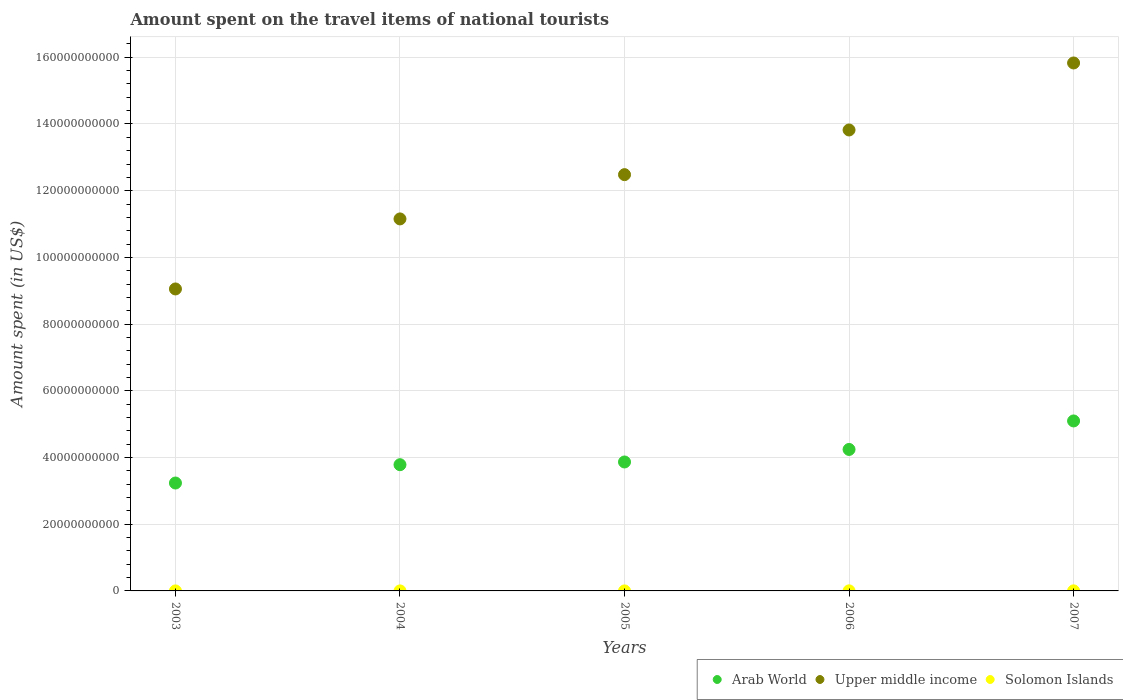What is the amount spent on the travel items of national tourists in Solomon Islands in 2007?
Your response must be concise. 2.26e+07. Across all years, what is the maximum amount spent on the travel items of national tourists in Upper middle income?
Your response must be concise. 1.58e+11. Across all years, what is the minimum amount spent on the travel items of national tourists in Solomon Islands?
Give a very brief answer. 1.50e+06. What is the total amount spent on the travel items of national tourists in Arab World in the graph?
Your response must be concise. 2.02e+11. What is the difference between the amount spent on the travel items of national tourists in Solomon Islands in 2004 and that in 2005?
Your answer should be very brief. 1.90e+06. What is the difference between the amount spent on the travel items of national tourists in Upper middle income in 2004 and the amount spent on the travel items of national tourists in Arab World in 2005?
Provide a succinct answer. 7.29e+1. What is the average amount spent on the travel items of national tourists in Solomon Islands per year?
Keep it short and to the point. 1.01e+07. In the year 2004, what is the difference between the amount spent on the travel items of national tourists in Solomon Islands and amount spent on the travel items of national tourists in Upper middle income?
Provide a short and direct response. -1.12e+11. In how many years, is the amount spent on the travel items of national tourists in Arab World greater than 16000000000 US$?
Give a very brief answer. 5. What is the ratio of the amount spent on the travel items of national tourists in Solomon Islands in 2005 to that in 2006?
Provide a short and direct response. 0.08. Is the difference between the amount spent on the travel items of national tourists in Solomon Islands in 2004 and 2005 greater than the difference between the amount spent on the travel items of national tourists in Upper middle income in 2004 and 2005?
Keep it short and to the point. Yes. What is the difference between the highest and the second highest amount spent on the travel items of national tourists in Arab World?
Your answer should be compact. 8.55e+09. What is the difference between the highest and the lowest amount spent on the travel items of national tourists in Arab World?
Keep it short and to the point. 1.86e+1. Is the sum of the amount spent on the travel items of national tourists in Arab World in 2004 and 2007 greater than the maximum amount spent on the travel items of national tourists in Solomon Islands across all years?
Make the answer very short. Yes. Is it the case that in every year, the sum of the amount spent on the travel items of national tourists in Solomon Islands and amount spent on the travel items of national tourists in Arab World  is greater than the amount spent on the travel items of national tourists in Upper middle income?
Make the answer very short. No. Does the amount spent on the travel items of national tourists in Upper middle income monotonically increase over the years?
Keep it short and to the point. Yes. Is the amount spent on the travel items of national tourists in Upper middle income strictly greater than the amount spent on the travel items of national tourists in Arab World over the years?
Offer a very short reply. Yes. Are the values on the major ticks of Y-axis written in scientific E-notation?
Give a very brief answer. No. Where does the legend appear in the graph?
Give a very brief answer. Bottom right. How many legend labels are there?
Keep it short and to the point. 3. What is the title of the graph?
Give a very brief answer. Amount spent on the travel items of national tourists. Does "American Samoa" appear as one of the legend labels in the graph?
Your response must be concise. No. What is the label or title of the X-axis?
Your answer should be compact. Years. What is the label or title of the Y-axis?
Ensure brevity in your answer.  Amount spent (in US$). What is the Amount spent (in US$) of Arab World in 2003?
Offer a very short reply. 3.24e+1. What is the Amount spent (in US$) of Upper middle income in 2003?
Keep it short and to the point. 9.05e+1. What is the Amount spent (in US$) in Solomon Islands in 2003?
Keep it short and to the point. 1.50e+06. What is the Amount spent (in US$) in Arab World in 2004?
Offer a very short reply. 3.78e+1. What is the Amount spent (in US$) in Upper middle income in 2004?
Provide a succinct answer. 1.12e+11. What is the Amount spent (in US$) in Solomon Islands in 2004?
Your answer should be compact. 3.50e+06. What is the Amount spent (in US$) in Arab World in 2005?
Ensure brevity in your answer.  3.87e+1. What is the Amount spent (in US$) of Upper middle income in 2005?
Offer a terse response. 1.25e+11. What is the Amount spent (in US$) of Solomon Islands in 2005?
Your answer should be compact. 1.60e+06. What is the Amount spent (in US$) in Arab World in 2006?
Your response must be concise. 4.24e+1. What is the Amount spent (in US$) in Upper middle income in 2006?
Give a very brief answer. 1.38e+11. What is the Amount spent (in US$) in Solomon Islands in 2006?
Offer a very short reply. 2.11e+07. What is the Amount spent (in US$) in Arab World in 2007?
Your answer should be compact. 5.10e+1. What is the Amount spent (in US$) of Upper middle income in 2007?
Provide a short and direct response. 1.58e+11. What is the Amount spent (in US$) in Solomon Islands in 2007?
Give a very brief answer. 2.26e+07. Across all years, what is the maximum Amount spent (in US$) in Arab World?
Make the answer very short. 5.10e+1. Across all years, what is the maximum Amount spent (in US$) in Upper middle income?
Your answer should be compact. 1.58e+11. Across all years, what is the maximum Amount spent (in US$) in Solomon Islands?
Provide a succinct answer. 2.26e+07. Across all years, what is the minimum Amount spent (in US$) of Arab World?
Offer a very short reply. 3.24e+1. Across all years, what is the minimum Amount spent (in US$) in Upper middle income?
Ensure brevity in your answer.  9.05e+1. Across all years, what is the minimum Amount spent (in US$) of Solomon Islands?
Give a very brief answer. 1.50e+06. What is the total Amount spent (in US$) in Arab World in the graph?
Your answer should be very brief. 2.02e+11. What is the total Amount spent (in US$) in Upper middle income in the graph?
Provide a short and direct response. 6.23e+11. What is the total Amount spent (in US$) in Solomon Islands in the graph?
Your answer should be compact. 5.03e+07. What is the difference between the Amount spent (in US$) of Arab World in 2003 and that in 2004?
Make the answer very short. -5.49e+09. What is the difference between the Amount spent (in US$) of Upper middle income in 2003 and that in 2004?
Provide a short and direct response. -2.10e+1. What is the difference between the Amount spent (in US$) in Solomon Islands in 2003 and that in 2004?
Provide a short and direct response. -2.00e+06. What is the difference between the Amount spent (in US$) of Arab World in 2003 and that in 2005?
Give a very brief answer. -6.31e+09. What is the difference between the Amount spent (in US$) of Upper middle income in 2003 and that in 2005?
Keep it short and to the point. -3.43e+1. What is the difference between the Amount spent (in US$) in Solomon Islands in 2003 and that in 2005?
Offer a terse response. -1.00e+05. What is the difference between the Amount spent (in US$) in Arab World in 2003 and that in 2006?
Ensure brevity in your answer.  -1.01e+1. What is the difference between the Amount spent (in US$) of Upper middle income in 2003 and that in 2006?
Offer a terse response. -4.77e+1. What is the difference between the Amount spent (in US$) of Solomon Islands in 2003 and that in 2006?
Provide a succinct answer. -1.96e+07. What is the difference between the Amount spent (in US$) of Arab World in 2003 and that in 2007?
Ensure brevity in your answer.  -1.86e+1. What is the difference between the Amount spent (in US$) in Upper middle income in 2003 and that in 2007?
Your answer should be compact. -6.78e+1. What is the difference between the Amount spent (in US$) of Solomon Islands in 2003 and that in 2007?
Provide a succinct answer. -2.11e+07. What is the difference between the Amount spent (in US$) in Arab World in 2004 and that in 2005?
Offer a terse response. -8.15e+08. What is the difference between the Amount spent (in US$) of Upper middle income in 2004 and that in 2005?
Provide a short and direct response. -1.33e+1. What is the difference between the Amount spent (in US$) of Solomon Islands in 2004 and that in 2005?
Offer a very short reply. 1.90e+06. What is the difference between the Amount spent (in US$) of Arab World in 2004 and that in 2006?
Offer a terse response. -4.57e+09. What is the difference between the Amount spent (in US$) of Upper middle income in 2004 and that in 2006?
Your answer should be compact. -2.67e+1. What is the difference between the Amount spent (in US$) in Solomon Islands in 2004 and that in 2006?
Provide a succinct answer. -1.76e+07. What is the difference between the Amount spent (in US$) in Arab World in 2004 and that in 2007?
Provide a succinct answer. -1.31e+1. What is the difference between the Amount spent (in US$) of Upper middle income in 2004 and that in 2007?
Your answer should be very brief. -4.68e+1. What is the difference between the Amount spent (in US$) of Solomon Islands in 2004 and that in 2007?
Provide a short and direct response. -1.91e+07. What is the difference between the Amount spent (in US$) of Arab World in 2005 and that in 2006?
Your answer should be very brief. -3.76e+09. What is the difference between the Amount spent (in US$) of Upper middle income in 2005 and that in 2006?
Give a very brief answer. -1.34e+1. What is the difference between the Amount spent (in US$) in Solomon Islands in 2005 and that in 2006?
Provide a succinct answer. -1.95e+07. What is the difference between the Amount spent (in US$) of Arab World in 2005 and that in 2007?
Offer a very short reply. -1.23e+1. What is the difference between the Amount spent (in US$) of Upper middle income in 2005 and that in 2007?
Your answer should be compact. -3.35e+1. What is the difference between the Amount spent (in US$) of Solomon Islands in 2005 and that in 2007?
Offer a terse response. -2.10e+07. What is the difference between the Amount spent (in US$) of Arab World in 2006 and that in 2007?
Offer a very short reply. -8.55e+09. What is the difference between the Amount spent (in US$) in Upper middle income in 2006 and that in 2007?
Your response must be concise. -2.01e+1. What is the difference between the Amount spent (in US$) in Solomon Islands in 2006 and that in 2007?
Your answer should be compact. -1.50e+06. What is the difference between the Amount spent (in US$) in Arab World in 2003 and the Amount spent (in US$) in Upper middle income in 2004?
Your answer should be compact. -7.92e+1. What is the difference between the Amount spent (in US$) in Arab World in 2003 and the Amount spent (in US$) in Solomon Islands in 2004?
Your response must be concise. 3.23e+1. What is the difference between the Amount spent (in US$) of Upper middle income in 2003 and the Amount spent (in US$) of Solomon Islands in 2004?
Offer a very short reply. 9.05e+1. What is the difference between the Amount spent (in US$) of Arab World in 2003 and the Amount spent (in US$) of Upper middle income in 2005?
Offer a terse response. -9.25e+1. What is the difference between the Amount spent (in US$) of Arab World in 2003 and the Amount spent (in US$) of Solomon Islands in 2005?
Make the answer very short. 3.24e+1. What is the difference between the Amount spent (in US$) in Upper middle income in 2003 and the Amount spent (in US$) in Solomon Islands in 2005?
Your response must be concise. 9.05e+1. What is the difference between the Amount spent (in US$) of Arab World in 2003 and the Amount spent (in US$) of Upper middle income in 2006?
Offer a terse response. -1.06e+11. What is the difference between the Amount spent (in US$) of Arab World in 2003 and the Amount spent (in US$) of Solomon Islands in 2006?
Your answer should be very brief. 3.23e+1. What is the difference between the Amount spent (in US$) in Upper middle income in 2003 and the Amount spent (in US$) in Solomon Islands in 2006?
Ensure brevity in your answer.  9.05e+1. What is the difference between the Amount spent (in US$) of Arab World in 2003 and the Amount spent (in US$) of Upper middle income in 2007?
Your answer should be compact. -1.26e+11. What is the difference between the Amount spent (in US$) in Arab World in 2003 and the Amount spent (in US$) in Solomon Islands in 2007?
Your answer should be compact. 3.23e+1. What is the difference between the Amount spent (in US$) of Upper middle income in 2003 and the Amount spent (in US$) of Solomon Islands in 2007?
Provide a short and direct response. 9.05e+1. What is the difference between the Amount spent (in US$) of Arab World in 2004 and the Amount spent (in US$) of Upper middle income in 2005?
Ensure brevity in your answer.  -8.70e+1. What is the difference between the Amount spent (in US$) in Arab World in 2004 and the Amount spent (in US$) in Solomon Islands in 2005?
Offer a terse response. 3.78e+1. What is the difference between the Amount spent (in US$) in Upper middle income in 2004 and the Amount spent (in US$) in Solomon Islands in 2005?
Offer a terse response. 1.12e+11. What is the difference between the Amount spent (in US$) in Arab World in 2004 and the Amount spent (in US$) in Upper middle income in 2006?
Provide a short and direct response. -1.00e+11. What is the difference between the Amount spent (in US$) in Arab World in 2004 and the Amount spent (in US$) in Solomon Islands in 2006?
Your response must be concise. 3.78e+1. What is the difference between the Amount spent (in US$) in Upper middle income in 2004 and the Amount spent (in US$) in Solomon Islands in 2006?
Provide a succinct answer. 1.12e+11. What is the difference between the Amount spent (in US$) in Arab World in 2004 and the Amount spent (in US$) in Upper middle income in 2007?
Your response must be concise. -1.20e+11. What is the difference between the Amount spent (in US$) in Arab World in 2004 and the Amount spent (in US$) in Solomon Islands in 2007?
Provide a succinct answer. 3.78e+1. What is the difference between the Amount spent (in US$) in Upper middle income in 2004 and the Amount spent (in US$) in Solomon Islands in 2007?
Your answer should be very brief. 1.12e+11. What is the difference between the Amount spent (in US$) in Arab World in 2005 and the Amount spent (in US$) in Upper middle income in 2006?
Give a very brief answer. -9.95e+1. What is the difference between the Amount spent (in US$) of Arab World in 2005 and the Amount spent (in US$) of Solomon Islands in 2006?
Your answer should be very brief. 3.86e+1. What is the difference between the Amount spent (in US$) of Upper middle income in 2005 and the Amount spent (in US$) of Solomon Islands in 2006?
Your response must be concise. 1.25e+11. What is the difference between the Amount spent (in US$) in Arab World in 2005 and the Amount spent (in US$) in Upper middle income in 2007?
Provide a short and direct response. -1.20e+11. What is the difference between the Amount spent (in US$) of Arab World in 2005 and the Amount spent (in US$) of Solomon Islands in 2007?
Keep it short and to the point. 3.86e+1. What is the difference between the Amount spent (in US$) in Upper middle income in 2005 and the Amount spent (in US$) in Solomon Islands in 2007?
Your answer should be compact. 1.25e+11. What is the difference between the Amount spent (in US$) of Arab World in 2006 and the Amount spent (in US$) of Upper middle income in 2007?
Provide a short and direct response. -1.16e+11. What is the difference between the Amount spent (in US$) in Arab World in 2006 and the Amount spent (in US$) in Solomon Islands in 2007?
Your answer should be very brief. 4.24e+1. What is the difference between the Amount spent (in US$) of Upper middle income in 2006 and the Amount spent (in US$) of Solomon Islands in 2007?
Your answer should be compact. 1.38e+11. What is the average Amount spent (in US$) of Arab World per year?
Your answer should be compact. 4.04e+1. What is the average Amount spent (in US$) of Upper middle income per year?
Ensure brevity in your answer.  1.25e+11. What is the average Amount spent (in US$) in Solomon Islands per year?
Offer a terse response. 1.01e+07. In the year 2003, what is the difference between the Amount spent (in US$) of Arab World and Amount spent (in US$) of Upper middle income?
Keep it short and to the point. -5.82e+1. In the year 2003, what is the difference between the Amount spent (in US$) in Arab World and Amount spent (in US$) in Solomon Islands?
Provide a short and direct response. 3.24e+1. In the year 2003, what is the difference between the Amount spent (in US$) in Upper middle income and Amount spent (in US$) in Solomon Islands?
Your answer should be very brief. 9.05e+1. In the year 2004, what is the difference between the Amount spent (in US$) of Arab World and Amount spent (in US$) of Upper middle income?
Keep it short and to the point. -7.37e+1. In the year 2004, what is the difference between the Amount spent (in US$) of Arab World and Amount spent (in US$) of Solomon Islands?
Your answer should be very brief. 3.78e+1. In the year 2004, what is the difference between the Amount spent (in US$) in Upper middle income and Amount spent (in US$) in Solomon Islands?
Give a very brief answer. 1.12e+11. In the year 2005, what is the difference between the Amount spent (in US$) of Arab World and Amount spent (in US$) of Upper middle income?
Offer a terse response. -8.62e+1. In the year 2005, what is the difference between the Amount spent (in US$) of Arab World and Amount spent (in US$) of Solomon Islands?
Your answer should be compact. 3.87e+1. In the year 2005, what is the difference between the Amount spent (in US$) in Upper middle income and Amount spent (in US$) in Solomon Islands?
Ensure brevity in your answer.  1.25e+11. In the year 2006, what is the difference between the Amount spent (in US$) of Arab World and Amount spent (in US$) of Upper middle income?
Your answer should be compact. -9.58e+1. In the year 2006, what is the difference between the Amount spent (in US$) of Arab World and Amount spent (in US$) of Solomon Islands?
Offer a very short reply. 4.24e+1. In the year 2006, what is the difference between the Amount spent (in US$) of Upper middle income and Amount spent (in US$) of Solomon Islands?
Your answer should be compact. 1.38e+11. In the year 2007, what is the difference between the Amount spent (in US$) of Arab World and Amount spent (in US$) of Upper middle income?
Provide a short and direct response. -1.07e+11. In the year 2007, what is the difference between the Amount spent (in US$) of Arab World and Amount spent (in US$) of Solomon Islands?
Offer a very short reply. 5.09e+1. In the year 2007, what is the difference between the Amount spent (in US$) of Upper middle income and Amount spent (in US$) of Solomon Islands?
Offer a very short reply. 1.58e+11. What is the ratio of the Amount spent (in US$) of Arab World in 2003 to that in 2004?
Provide a short and direct response. 0.85. What is the ratio of the Amount spent (in US$) of Upper middle income in 2003 to that in 2004?
Provide a short and direct response. 0.81. What is the ratio of the Amount spent (in US$) of Solomon Islands in 2003 to that in 2004?
Ensure brevity in your answer.  0.43. What is the ratio of the Amount spent (in US$) in Arab World in 2003 to that in 2005?
Your response must be concise. 0.84. What is the ratio of the Amount spent (in US$) of Upper middle income in 2003 to that in 2005?
Offer a terse response. 0.73. What is the ratio of the Amount spent (in US$) of Arab World in 2003 to that in 2006?
Offer a terse response. 0.76. What is the ratio of the Amount spent (in US$) in Upper middle income in 2003 to that in 2006?
Provide a short and direct response. 0.66. What is the ratio of the Amount spent (in US$) of Solomon Islands in 2003 to that in 2006?
Make the answer very short. 0.07. What is the ratio of the Amount spent (in US$) in Arab World in 2003 to that in 2007?
Your answer should be very brief. 0.63. What is the ratio of the Amount spent (in US$) of Upper middle income in 2003 to that in 2007?
Keep it short and to the point. 0.57. What is the ratio of the Amount spent (in US$) of Solomon Islands in 2003 to that in 2007?
Keep it short and to the point. 0.07. What is the ratio of the Amount spent (in US$) in Arab World in 2004 to that in 2005?
Give a very brief answer. 0.98. What is the ratio of the Amount spent (in US$) of Upper middle income in 2004 to that in 2005?
Your answer should be very brief. 0.89. What is the ratio of the Amount spent (in US$) in Solomon Islands in 2004 to that in 2005?
Offer a very short reply. 2.19. What is the ratio of the Amount spent (in US$) in Arab World in 2004 to that in 2006?
Your response must be concise. 0.89. What is the ratio of the Amount spent (in US$) of Upper middle income in 2004 to that in 2006?
Make the answer very short. 0.81. What is the ratio of the Amount spent (in US$) in Solomon Islands in 2004 to that in 2006?
Your answer should be very brief. 0.17. What is the ratio of the Amount spent (in US$) of Arab World in 2004 to that in 2007?
Provide a short and direct response. 0.74. What is the ratio of the Amount spent (in US$) of Upper middle income in 2004 to that in 2007?
Give a very brief answer. 0.7. What is the ratio of the Amount spent (in US$) in Solomon Islands in 2004 to that in 2007?
Keep it short and to the point. 0.15. What is the ratio of the Amount spent (in US$) in Arab World in 2005 to that in 2006?
Provide a succinct answer. 0.91. What is the ratio of the Amount spent (in US$) in Upper middle income in 2005 to that in 2006?
Your answer should be very brief. 0.9. What is the ratio of the Amount spent (in US$) of Solomon Islands in 2005 to that in 2006?
Make the answer very short. 0.08. What is the ratio of the Amount spent (in US$) of Arab World in 2005 to that in 2007?
Provide a succinct answer. 0.76. What is the ratio of the Amount spent (in US$) of Upper middle income in 2005 to that in 2007?
Provide a succinct answer. 0.79. What is the ratio of the Amount spent (in US$) in Solomon Islands in 2005 to that in 2007?
Ensure brevity in your answer.  0.07. What is the ratio of the Amount spent (in US$) of Arab World in 2006 to that in 2007?
Provide a short and direct response. 0.83. What is the ratio of the Amount spent (in US$) in Upper middle income in 2006 to that in 2007?
Offer a very short reply. 0.87. What is the ratio of the Amount spent (in US$) in Solomon Islands in 2006 to that in 2007?
Your response must be concise. 0.93. What is the difference between the highest and the second highest Amount spent (in US$) of Arab World?
Give a very brief answer. 8.55e+09. What is the difference between the highest and the second highest Amount spent (in US$) of Upper middle income?
Give a very brief answer. 2.01e+1. What is the difference between the highest and the second highest Amount spent (in US$) of Solomon Islands?
Provide a succinct answer. 1.50e+06. What is the difference between the highest and the lowest Amount spent (in US$) in Arab World?
Offer a very short reply. 1.86e+1. What is the difference between the highest and the lowest Amount spent (in US$) of Upper middle income?
Offer a terse response. 6.78e+1. What is the difference between the highest and the lowest Amount spent (in US$) in Solomon Islands?
Your response must be concise. 2.11e+07. 